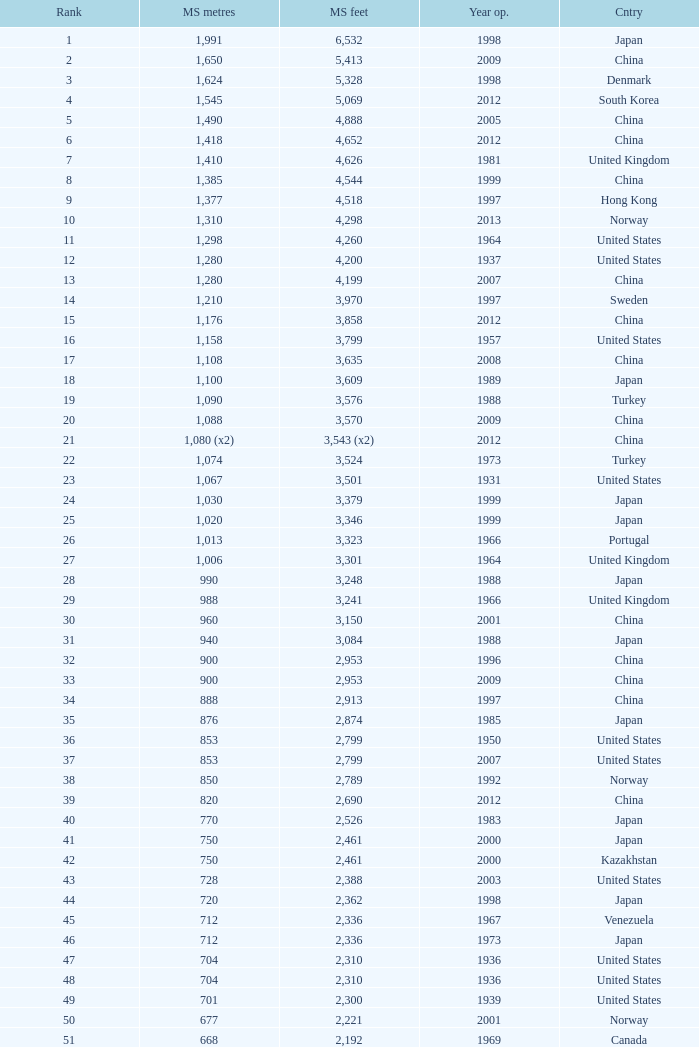In south korea, which is the most ancient year featuring a main span of 1,640 feet? 2002.0. 